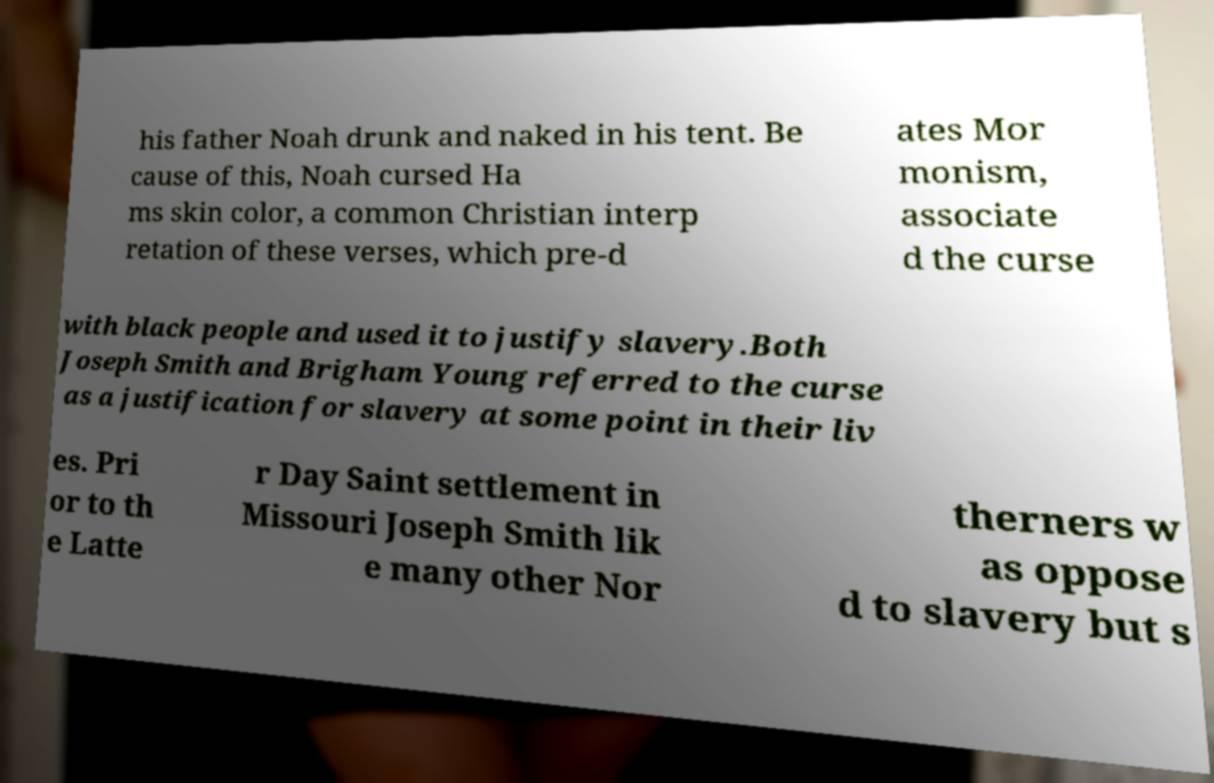For documentation purposes, I need the text within this image transcribed. Could you provide that? his father Noah drunk and naked in his tent. Be cause of this, Noah cursed Ha ms skin color, a common Christian interp retation of these verses, which pre-d ates Mor monism, associate d the curse with black people and used it to justify slavery.Both Joseph Smith and Brigham Young referred to the curse as a justification for slavery at some point in their liv es. Pri or to th e Latte r Day Saint settlement in Missouri Joseph Smith lik e many other Nor therners w as oppose d to slavery but s 